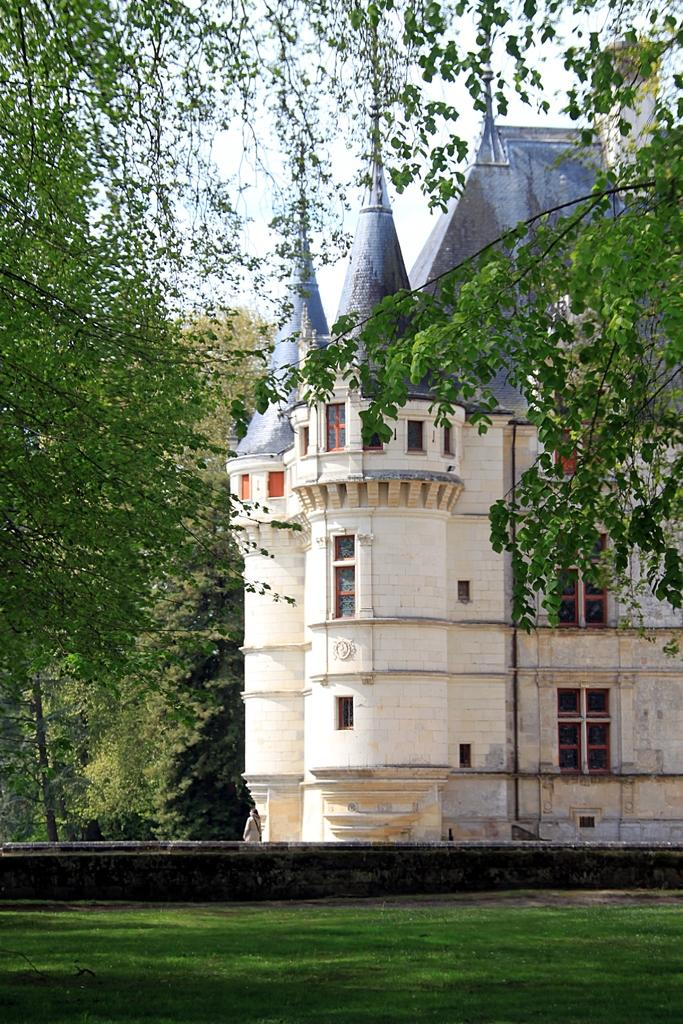What is the main structure in the center of the image? There is a castle in the center of the image. What type of vegetation can be seen on the left side of the image? There are trees on the left side of the image. What type of vegetation can be seen on the right side of the image? There are trees on the right side of the image. What type of ground is visible at the bottom of the image? There is grass at the bottom of the image. What is visible in the background of the image? The sky is visible in the background of the image. What type of chess piece is located on the top of the castle in the image? There is no chess piece present on the top of the castle in the image. How much debt is represented by the trees on the left side of the image? There is no debt represented by the trees in the image; they are simply trees. 